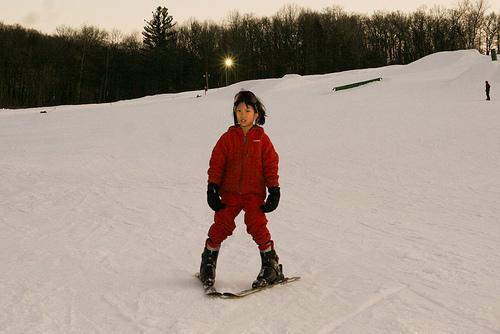How many people in the photo?
Give a very brief answer. 2. 